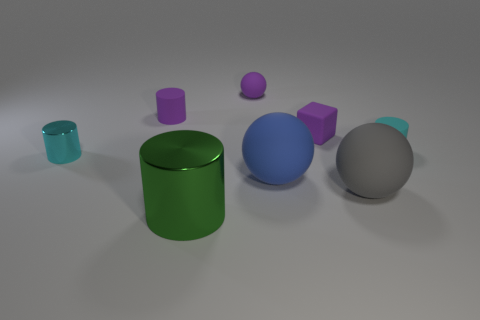Do the blue thing and the big gray rubber object have the same shape?
Give a very brief answer. Yes. There is a metallic thing behind the matte ball to the right of the large rubber sphere behind the gray rubber sphere; how big is it?
Your answer should be very brief. Small. What number of other things are the same material as the gray ball?
Ensure brevity in your answer.  5. The cylinder that is to the right of the purple matte block is what color?
Your response must be concise. Cyan. What is the tiny cyan cylinder behind the cyan cylinder that is in front of the cyan thing on the right side of the big green metal cylinder made of?
Offer a terse response. Rubber. Is there another tiny cyan shiny thing of the same shape as the small metallic object?
Provide a succinct answer. No. The green object that is the same size as the blue ball is what shape?
Your response must be concise. Cylinder. How many things are both behind the large blue matte object and in front of the small purple rubber ball?
Give a very brief answer. 4. Is the number of matte things to the right of the green shiny cylinder less than the number of cyan shiny things?
Your response must be concise. No. Is there a cyan matte cylinder of the same size as the gray ball?
Give a very brief answer. No. 